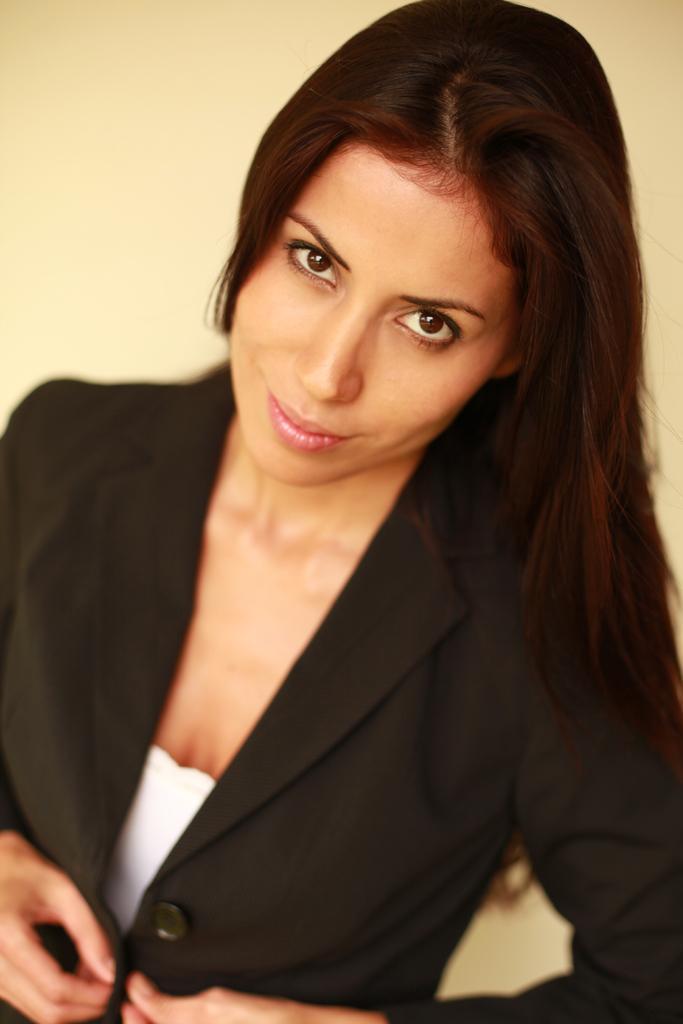Describe this image in one or two sentences. In this image we can see a woman wearing black color blazer. 